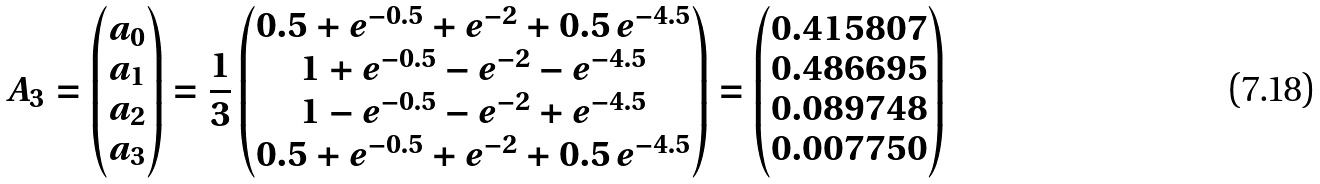Convert formula to latex. <formula><loc_0><loc_0><loc_500><loc_500>A _ { 3 } = \begin{pmatrix} a _ { 0 } \\ a _ { 1 } \\ a _ { 2 } \\ a _ { 3 } \end{pmatrix} = \frac { 1 } { 3 } \begin{pmatrix} 0 . 5 + e ^ { - 0 . 5 } + e ^ { - 2 } + 0 . 5 \, e ^ { - 4 . 5 } \\ 1 + e ^ { - 0 . 5 } - e ^ { - 2 } - e ^ { - 4 . 5 } \\ 1 - e ^ { - 0 . 5 } - e ^ { - 2 } + e ^ { - 4 . 5 } \\ 0 . 5 + e ^ { - 0 . 5 } + e ^ { - 2 } + 0 . 5 \, e ^ { - 4 . 5 } \\ \end{pmatrix} = \begin{pmatrix} 0 . 4 1 5 8 0 7 \\ 0 . 4 8 6 6 9 5 \\ 0 . 0 8 9 7 4 8 \\ 0 . 0 0 7 7 5 0 \\ \end{pmatrix}</formula> 